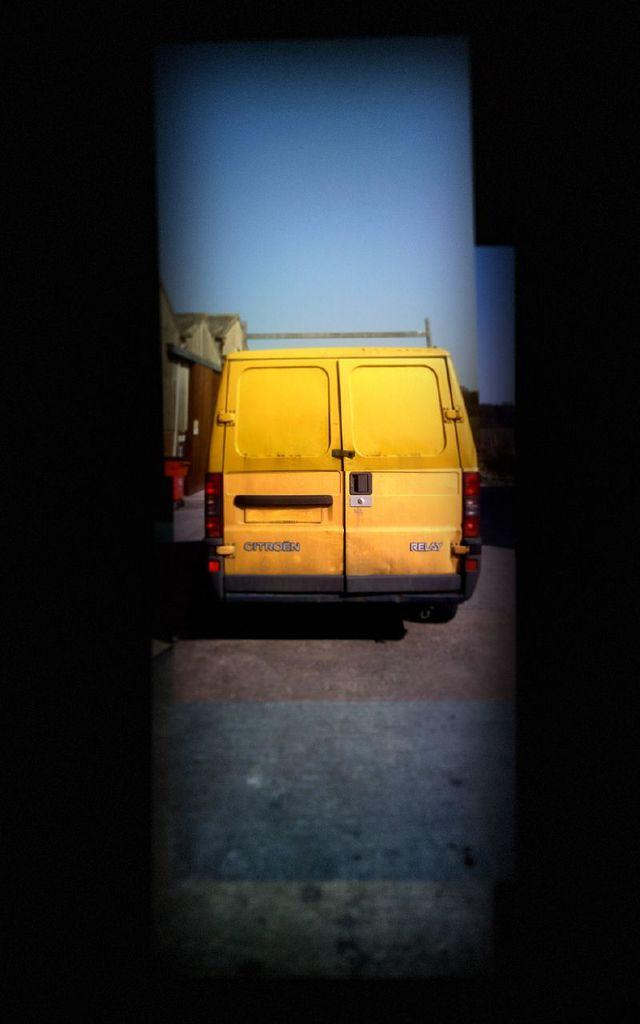What is on the road in the image? There is a vehicle on the road in the image. What type of structure can be seen in the image? There is a house in the image. What is visible in the background of the image? The sky is visible in the background of the image. What type of sock is hanging on the clothesline in the image? There is no sock or clothesline present in the image. What season is depicted in the image? The provided facts do not mention any seasonal details, so it cannot be determined from the image. 